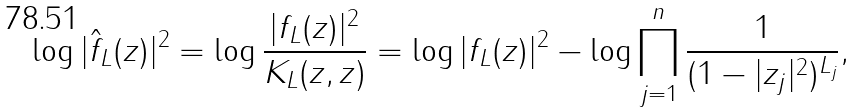Convert formula to latex. <formula><loc_0><loc_0><loc_500><loc_500>\log | \hat { f } _ { L } ( z ) | ^ { 2 } = \log \frac { | f _ { L } ( z ) | ^ { 2 } } { K _ { L } ( z , z ) } & = \log | f _ { L } ( z ) | ^ { 2 } - \log \prod _ { j = 1 } ^ { n } \frac { 1 } { ( 1 - | z _ { j } | ^ { 2 } ) ^ { L _ { j } } } ,</formula> 